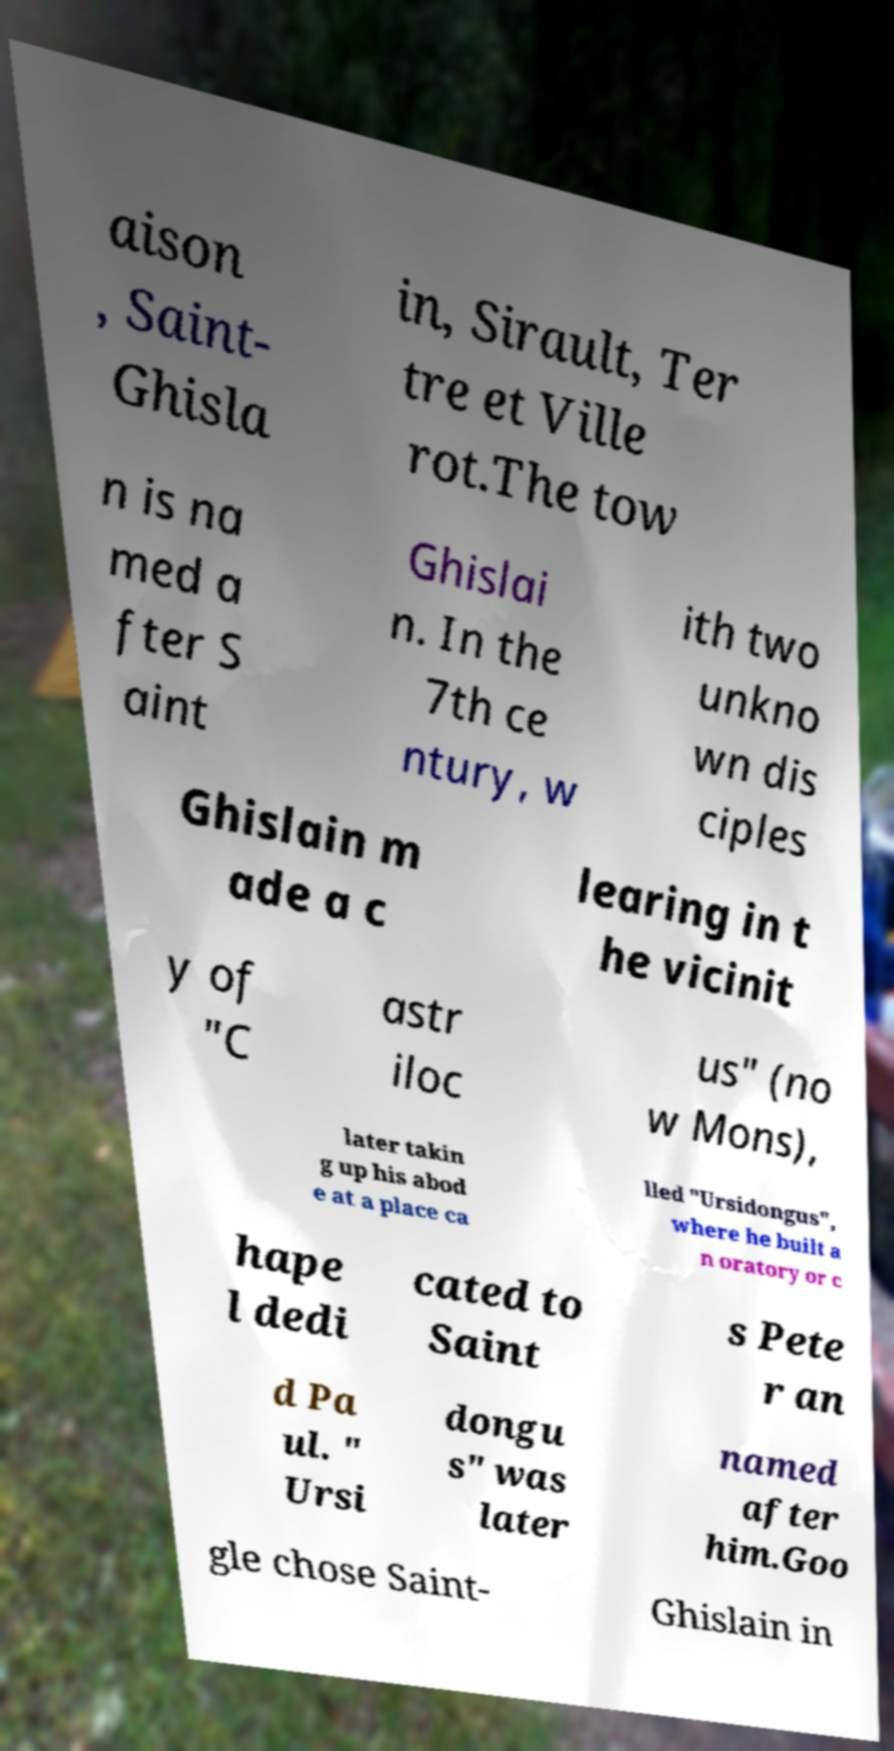I need the written content from this picture converted into text. Can you do that? aison , Saint- Ghisla in, Sirault, Ter tre et Ville rot.The tow n is na med a fter S aint Ghislai n. In the 7th ce ntury, w ith two unkno wn dis ciples Ghislain m ade a c learing in t he vicinit y of "C astr iloc us" (no w Mons), later takin g up his abod e at a place ca lled "Ursidongus", where he built a n oratory or c hape l dedi cated to Saint s Pete r an d Pa ul. " Ursi dongu s" was later named after him.Goo gle chose Saint- Ghislain in 